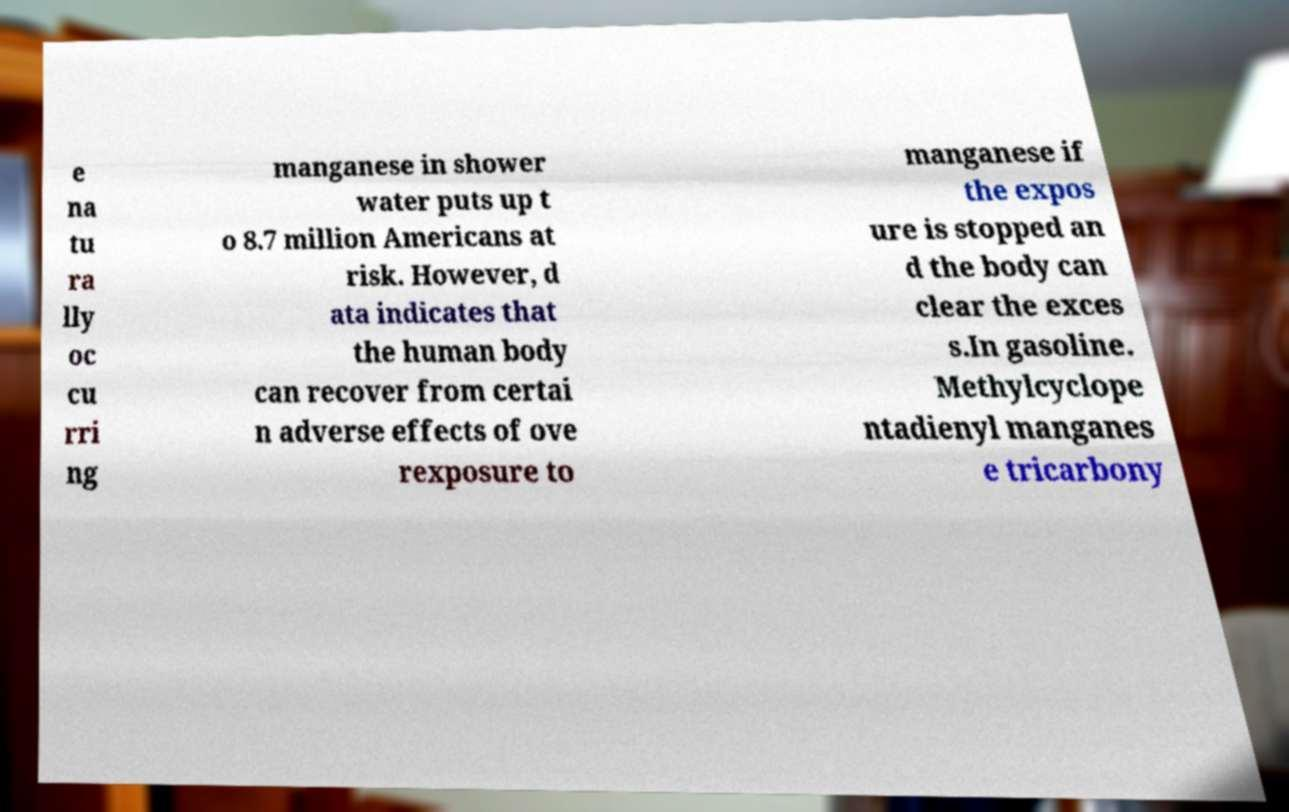There's text embedded in this image that I need extracted. Can you transcribe it verbatim? e na tu ra lly oc cu rri ng manganese in shower water puts up t o 8.7 million Americans at risk. However, d ata indicates that the human body can recover from certai n adverse effects of ove rexposure to manganese if the expos ure is stopped an d the body can clear the exces s.In gasoline. Methylcyclope ntadienyl manganes e tricarbony 